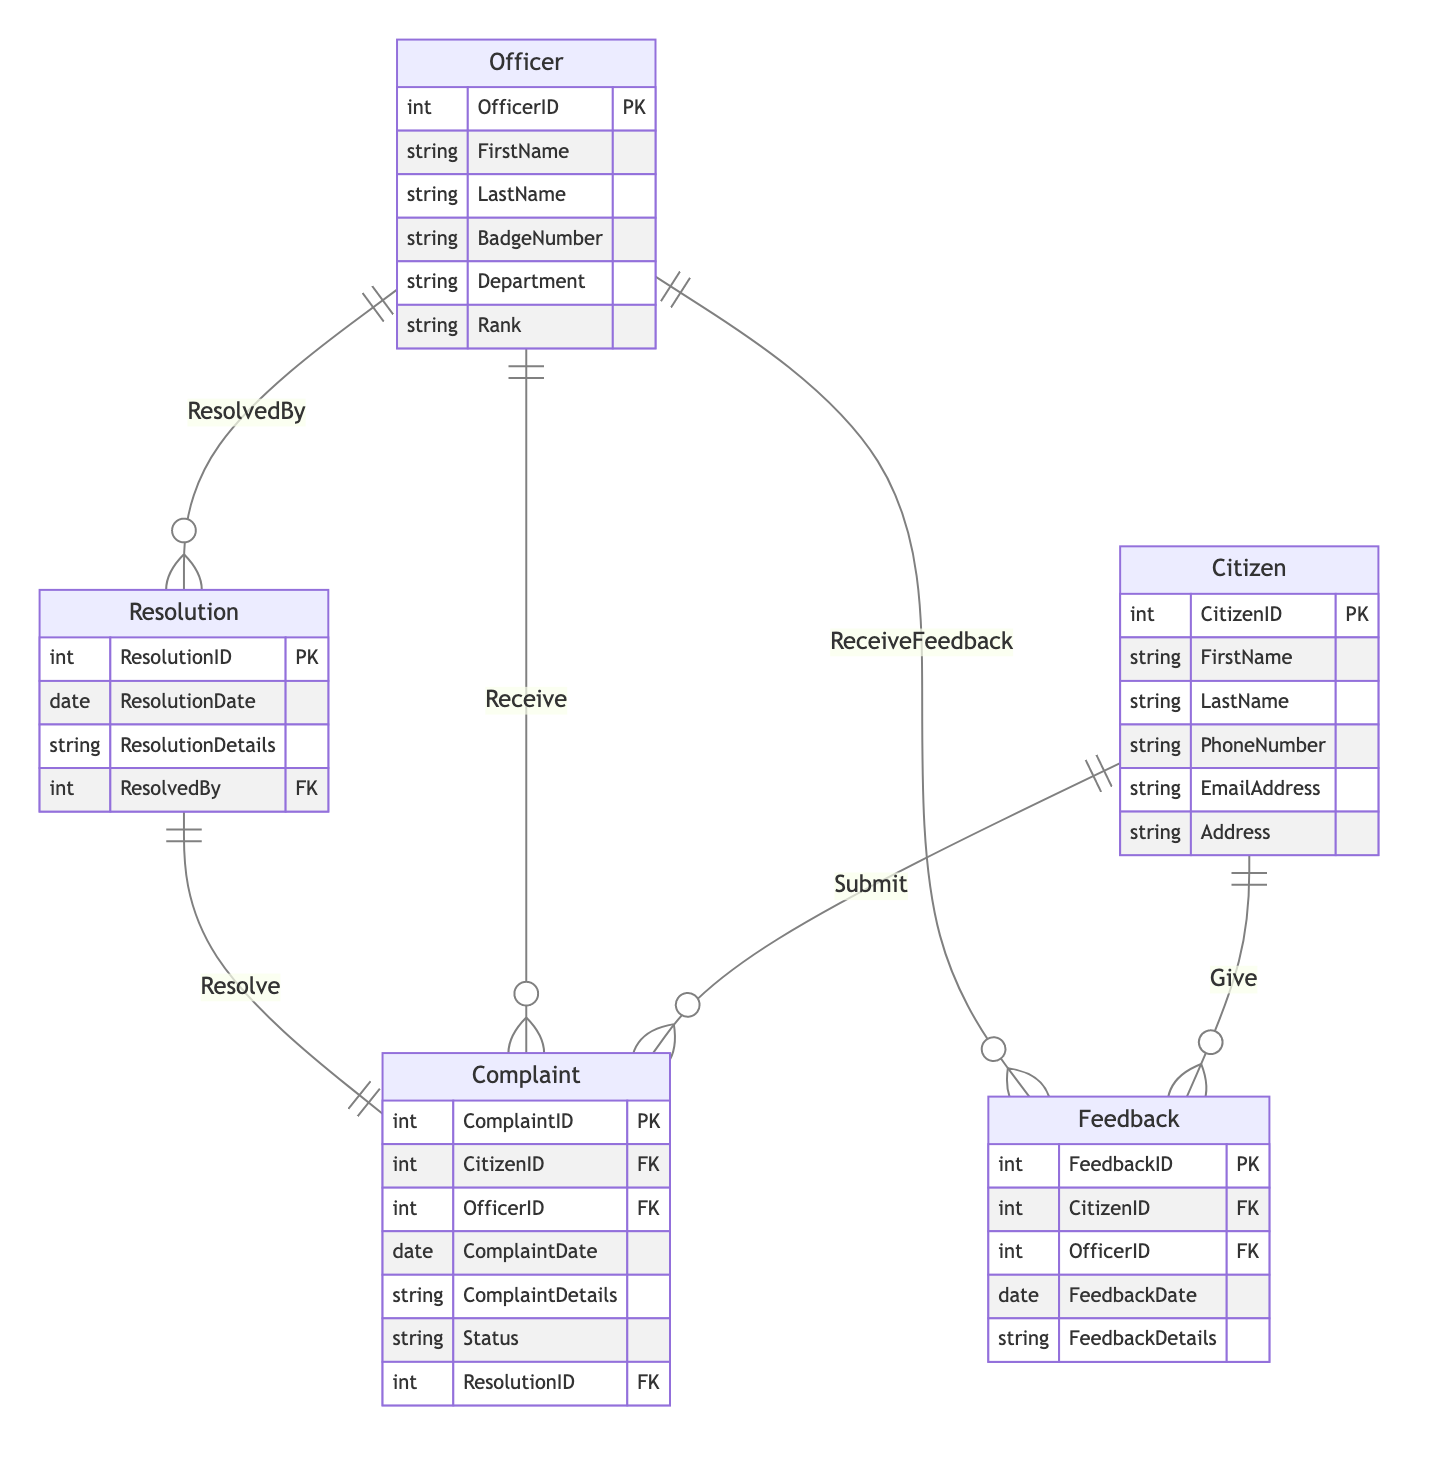What's the primary key of the Citizen entity? The primary key is defined in the Citizen entity section, and it is labeled as CitizenID. This uniquely identifies each citizen in the system.
Answer: CitizenID How many attributes does the Complaint entity have? The Complaint entity includes a list of attributes, which are ComplaintID, CitizenID, OfficerID, ComplaintDate, ComplaintDetails, Status, and ResolutionID. Counting these gives a total of seven attributes.
Answer: 7 What relationship exists between Officer and Complaint? Reviewing the relationship section, we find that the Officer entity has a one-to-many relationship with the Complaint entity called Receive. This indicates that one officer can receive multiple complaints.
Answer: Receive Which entity can resolve complaints? According to the relationships, the Resolution entity indicates a one-to-one relationship with the Complaint entity through the Resolve relationship. The officer who resolves a complaint is referenced in the Resolution entity, specifically under ResolvedBy. Therefore, the Resolution entity involves the officer in resolving complaints.
Answer: Resolution What is the foreign key in the Feedback entity referencing? The Feedback entity lists CitizenID and OfficerID as foreign keys. These reference the Citizen and Officer entities, respectively. They establish connections between feedback given and the specific citizen and officer involved in the interaction.
Answer: Citizen and Officer How many entities are interconnected with the Complaint entity? The Complaint entity connects to multiple other entities: Citizen, Officer, and Resolution, as reflected in the foreign key relationships. Each relationship shows how complaints are linked to the entities, totaling three entities interconnected with Complaints.
Answer: 3 What does the relationship named "Give" signify? The relationship "Give" represents a one-to-many connection from Citizen to Feedback, indicating that a single citizen can provide multiple feedback entries. This reflects how citizens can give feedback regarding interactions with officers.
Answer: One-to-many Which officer is involved in a resolution? The Resolution entity contains a foreign key named ResolvedBy, which indicates that one of the officers is associated with each resolution of a complaint. This indicates the specific officer responsible for resolving a complaint recorded in the system.
Answer: ResolvedBy What defines the status of a complaint? The Complaint entity includes an attribute called Status, which helps identify the current state or progress of a complaint in the system. This field would be used to assess whether a complaint is pending, resolved, or closed.
Answer: Status 